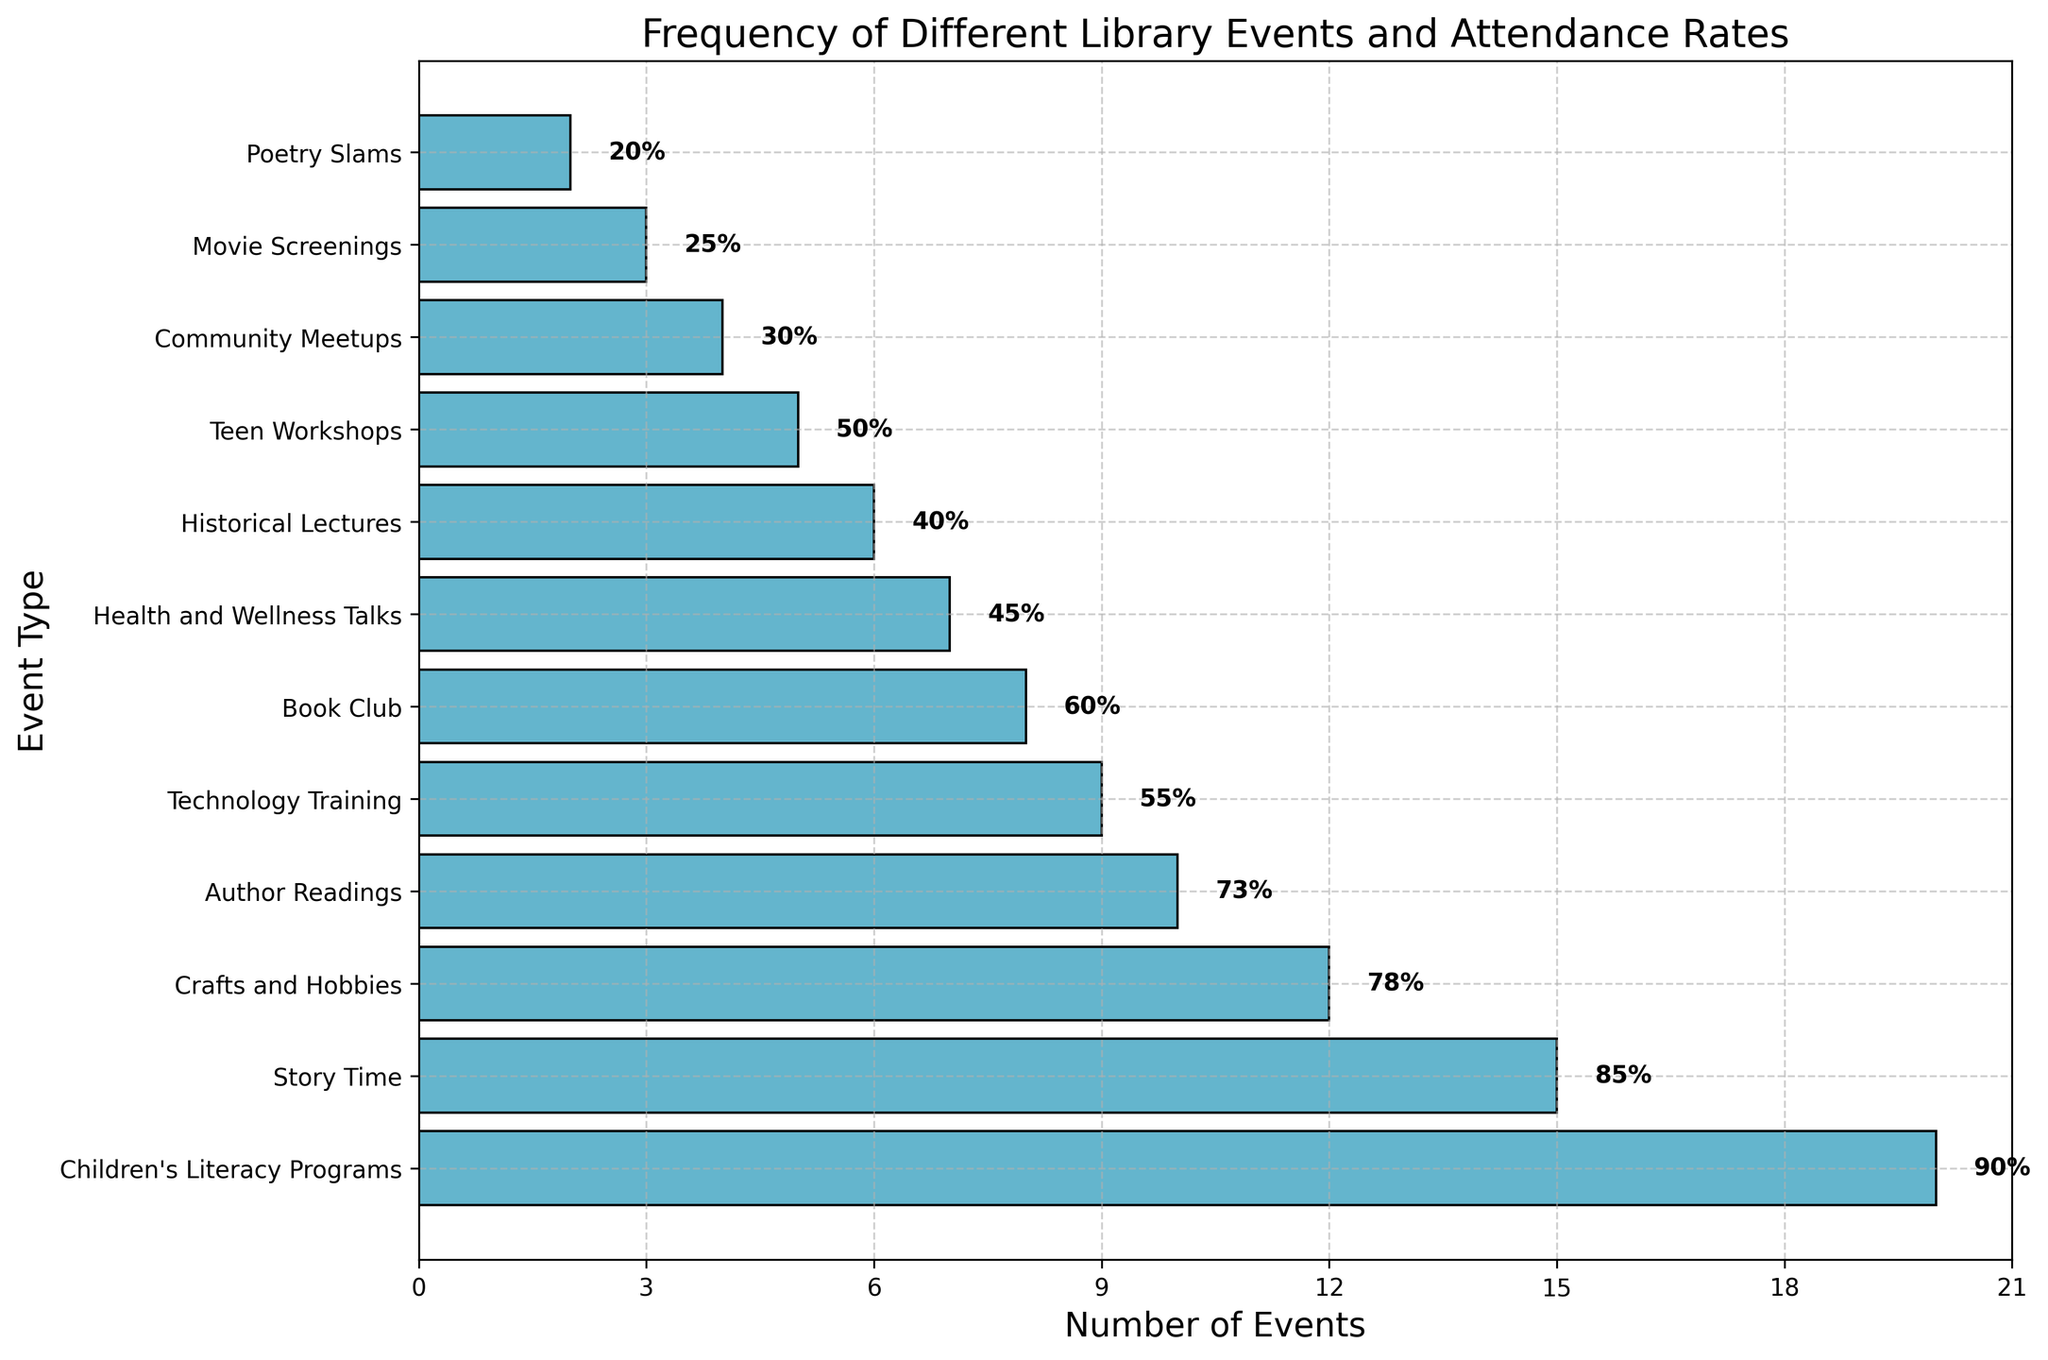Which event type has the highest frequency? The event type with the highest frequency is "Children's Literacy Programs," shown by the longest bar on the chart.
Answer: Children's Literacy Programs Which event type has the lowest attendance rate? "Poetry Slams" has the lowest attendance rate, as indicated by the 20% label next to the smallest bar.
Answer: Poetry Slams What is the total number of events for Story Time and Crafts and Hobbies combined? Sum the frequencies of "Story Time" (15) and "Crafts and Hobbies" (12). The total is 15 + 12 = 27.
Answer: 27 Which event types have an attendance rate greater than 70%? "Story Time" (85%), "Author Readings" (73%), "Crafts and Hobbies" (78%), and "Children's Literacy Programs" (90%) have attendance rates over 70%, as indicated by the labels next to their bars.
Answer: Story Time, Author Readings, Crafts and Hobbies, Children's Literacy Programs Are there more Book Club events or Teen Workshops? Compare the lengths of the bars for "Book Club" (8 events) and "Teen Workshops" (5 events); "Book Club" has more.
Answer: Book Club Which event has a higher attendance rate: Historical Lectures or Technology Training? Compare the attendance rates: "Historical Lectures" at 40% and "Technology Training" at 55%. Technology Training is higher.
Answer: Technology Training What is the sum of the attendance rates for the events with the lowest and highest frequencies? Sum the attendance rates for "Poetry Slams" (20%) and "Children's Literacy Programs" (90%). The total is 20% + 90% = 110%.
Answer: 110% Which event type has a frequency closest to the median frequency? First, list the frequencies: 2, 3, 4, 5, 6, 7, 8, 9, 10, 12, 15, 20. The median value (middle value) is the average of the 6th and 7th values: (7 + 8) / 2 = 7.5. The closest event frequencies to 7.5 are "Health and Wellness Talks" with 7 and "Book Club" with 8.
Answer: Health and Wellness Talks, Book Club What is the difference in attendance rates between the highest and lowest frequency events? "Children's Literacy Programs" has the highest frequency with a 90% attendance rate, and "Poetry Slams" has the lowest frequency with a 20% attendance rate. The difference is 90% - 20% = 70%.
Answer: 70% How many event types have a frequency of 10 or higher? Count the bars with frequencies of 10 or higher: "Story Time" (15), "Author Readings" (10), "Crafts and Hobbies" (12), and "Children's Literacy Programs" (20). There are 4 such events.
Answer: 4 